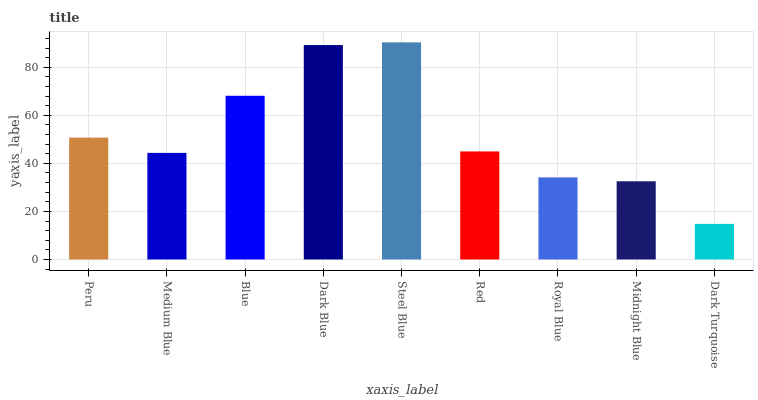Is Dark Turquoise the minimum?
Answer yes or no. Yes. Is Steel Blue the maximum?
Answer yes or no. Yes. Is Medium Blue the minimum?
Answer yes or no. No. Is Medium Blue the maximum?
Answer yes or no. No. Is Peru greater than Medium Blue?
Answer yes or no. Yes. Is Medium Blue less than Peru?
Answer yes or no. Yes. Is Medium Blue greater than Peru?
Answer yes or no. No. Is Peru less than Medium Blue?
Answer yes or no. No. Is Red the high median?
Answer yes or no. Yes. Is Red the low median?
Answer yes or no. Yes. Is Blue the high median?
Answer yes or no. No. Is Peru the low median?
Answer yes or no. No. 